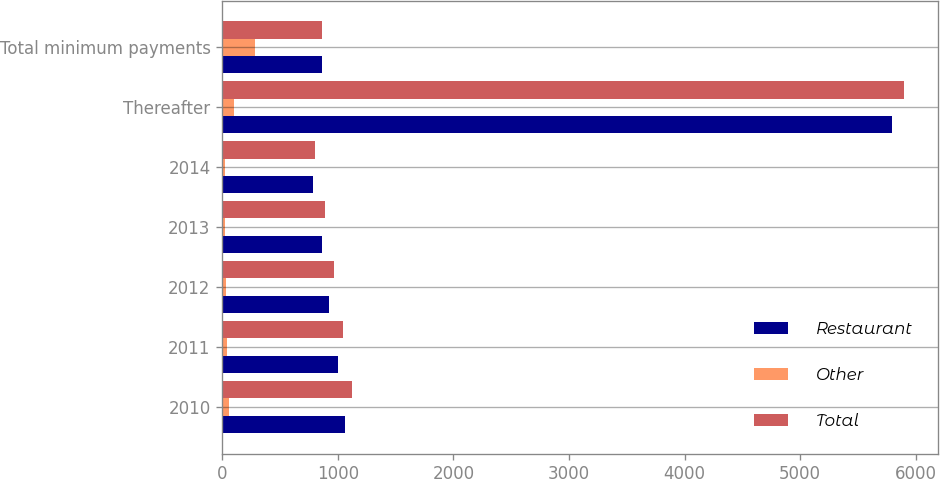<chart> <loc_0><loc_0><loc_500><loc_500><stacked_bar_chart><ecel><fcel>2010<fcel>2011<fcel>2012<fcel>2013<fcel>2014<fcel>Thereafter<fcel>Total minimum payments<nl><fcel>Restaurant<fcel>1064.7<fcel>1002.4<fcel>928.1<fcel>859.8<fcel>783.9<fcel>5794.5<fcel>859.8<nl><fcel>Other<fcel>54.7<fcel>44.1<fcel>35.3<fcel>25.6<fcel>22<fcel>102.4<fcel>284.1<nl><fcel>Total<fcel>1119.4<fcel>1046.5<fcel>963.4<fcel>885.4<fcel>805.9<fcel>5896.9<fcel>859.8<nl></chart> 